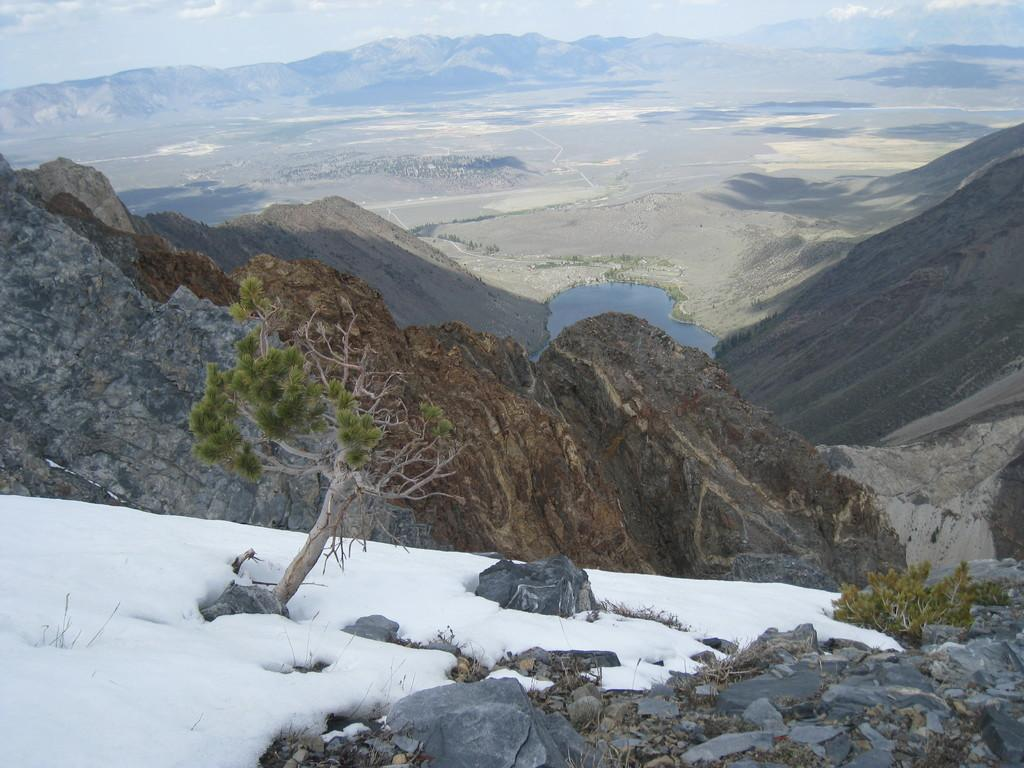What type of vegetation is present in the image? There is a tree in the image. What is the weather like in the image? There is snow in the image, indicating a cold climate. What type of terrain can be seen in the image? There are stones and mountains visible in the image. What body of water is present in the image? There is water visible in the image. What type of landscape can be seen in the background of the image? There is land visible in the background of the image. Who is the manager of the fight that is taking place in the image? There is no fight present in the image; it features a tree, snow, stones, mountains, water, and land. What type of fuel is being used by the vehicles in the image? There are no vehicles present in the image, so it is not possible to determine what type of fuel is being used. 